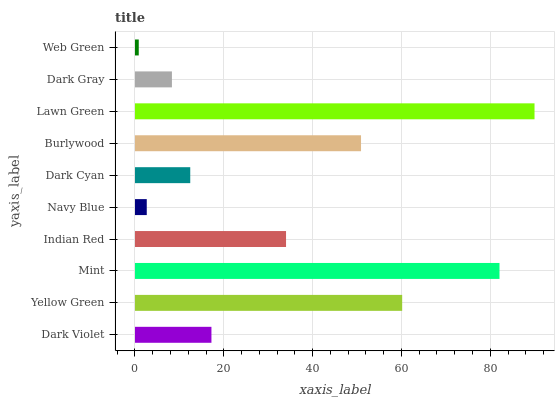Is Web Green the minimum?
Answer yes or no. Yes. Is Lawn Green the maximum?
Answer yes or no. Yes. Is Yellow Green the minimum?
Answer yes or no. No. Is Yellow Green the maximum?
Answer yes or no. No. Is Yellow Green greater than Dark Violet?
Answer yes or no. Yes. Is Dark Violet less than Yellow Green?
Answer yes or no. Yes. Is Dark Violet greater than Yellow Green?
Answer yes or no. No. Is Yellow Green less than Dark Violet?
Answer yes or no. No. Is Indian Red the high median?
Answer yes or no. Yes. Is Dark Violet the low median?
Answer yes or no. Yes. Is Dark Violet the high median?
Answer yes or no. No. Is Web Green the low median?
Answer yes or no. No. 